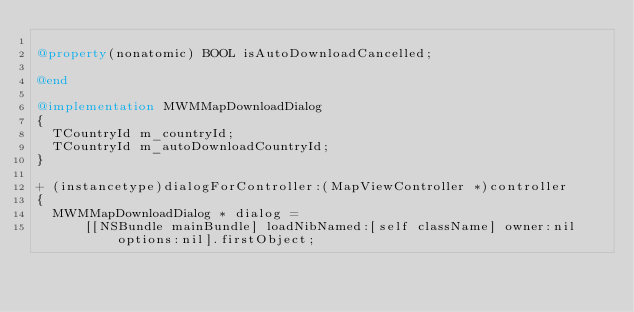<code> <loc_0><loc_0><loc_500><loc_500><_ObjectiveC_>
@property(nonatomic) BOOL isAutoDownloadCancelled;

@end

@implementation MWMMapDownloadDialog
{
  TCountryId m_countryId;
  TCountryId m_autoDownloadCountryId;
}

+ (instancetype)dialogForController:(MapViewController *)controller
{
  MWMMapDownloadDialog * dialog =
      [[NSBundle mainBundle] loadNibNamed:[self className] owner:nil options:nil].firstObject;</code> 